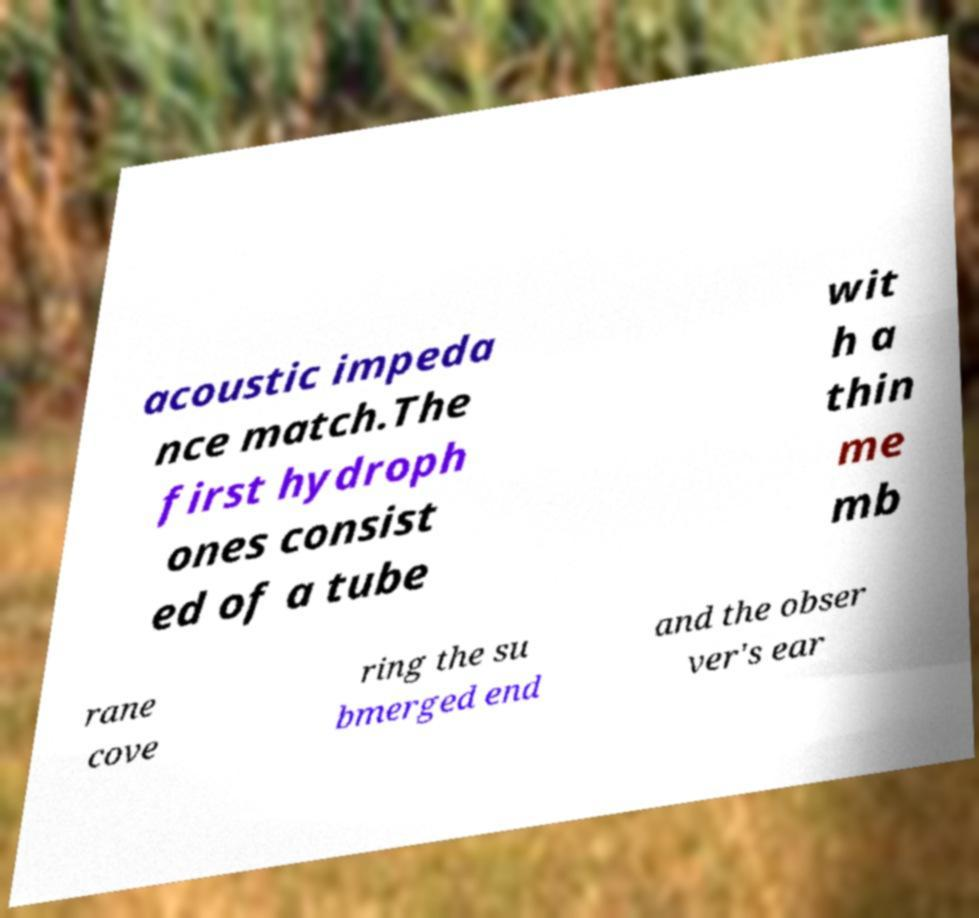Could you assist in decoding the text presented in this image and type it out clearly? acoustic impeda nce match.The first hydroph ones consist ed of a tube wit h a thin me mb rane cove ring the su bmerged end and the obser ver's ear 